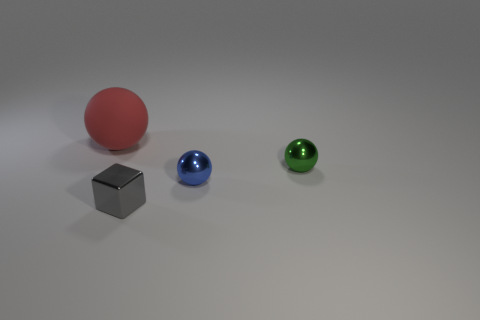Add 4 tiny gray blocks. How many objects exist? 8 Subtract all small spheres. How many spheres are left? 1 Add 4 big balls. How many big balls exist? 5 Subtract all green spheres. How many spheres are left? 2 Subtract 0 red cylinders. How many objects are left? 4 Subtract all balls. How many objects are left? 1 Subtract 1 balls. How many balls are left? 2 Subtract all red balls. Subtract all cyan cubes. How many balls are left? 2 Subtract all green cylinders. How many purple blocks are left? 0 Subtract all tiny cubes. Subtract all matte balls. How many objects are left? 2 